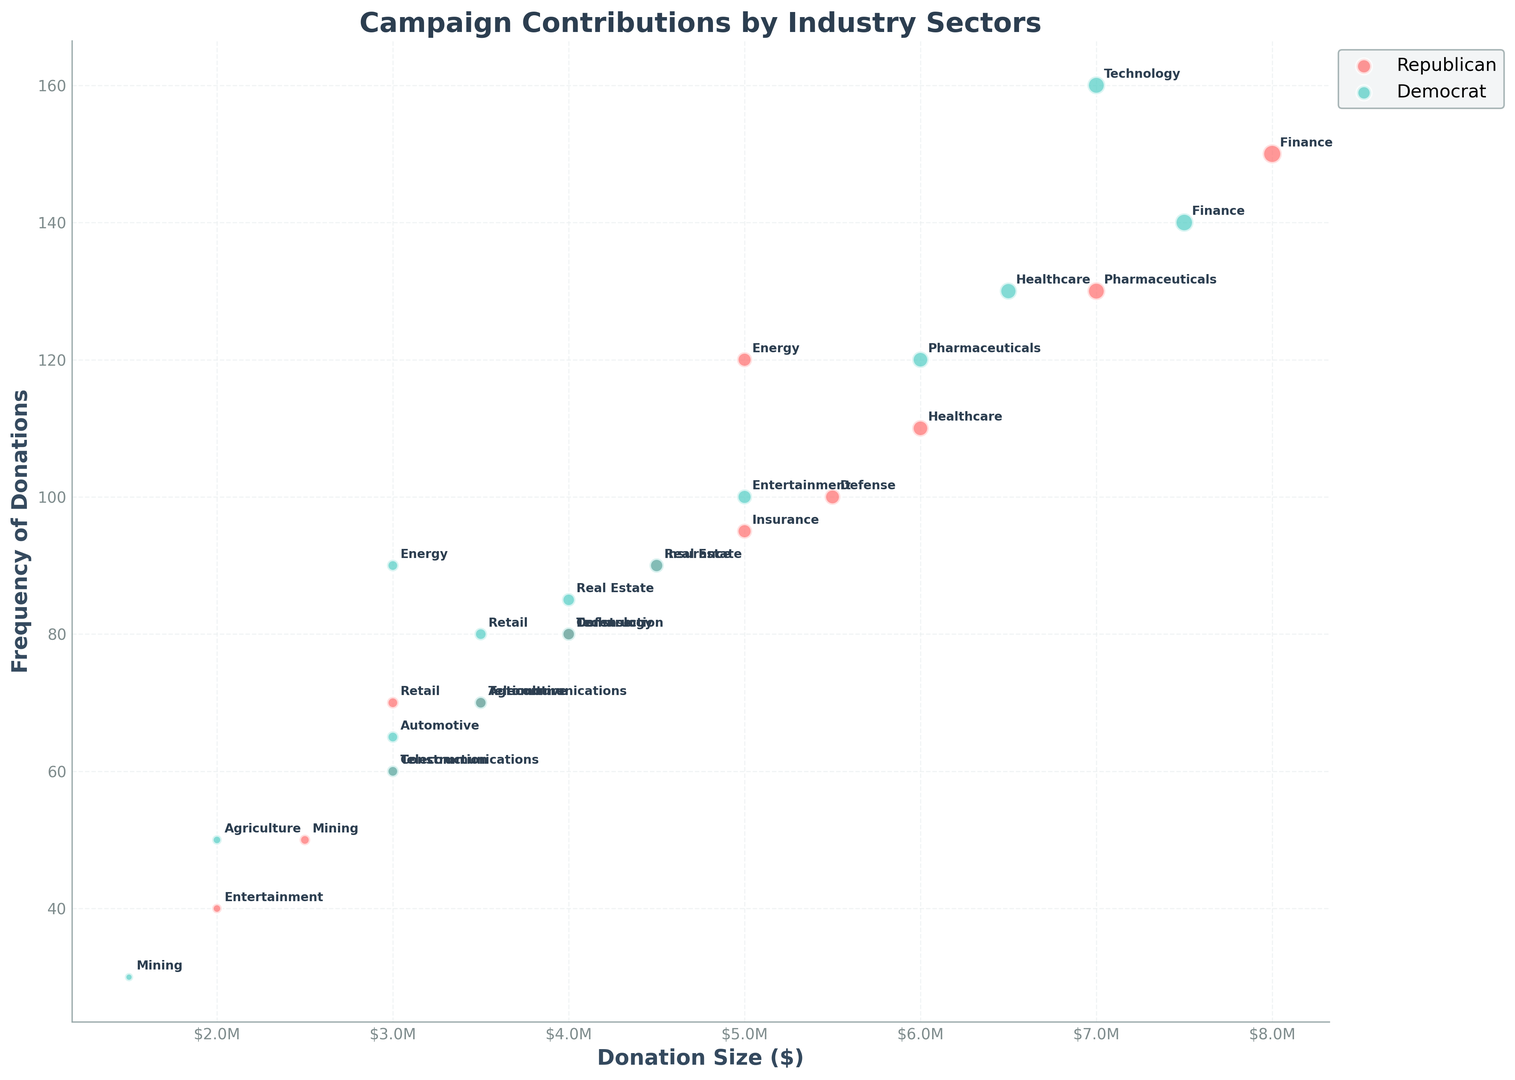Which industry contributes the largest total donation size to the Republican party? The total donation sizes to the Republican party are marked by larger bubble sizes. From the chart, the Finance sector has the largest bubble, indicating it has the largest total donation size.
Answer: Finance Which party receives more frequent contributions from the Technology sector? The Technology sector bubbles are positioned along the frequency axis. The Democrat bubble for Technology is higher on the frequency axis compared to the Republican bubble, indicating more frequent contributions.
Answer: Democrat What is the difference in average donation size between the Republican and Democrat parties, based on the Finance and Technology sectors? The Finance donations are $8M for Republicans and $7.5M for Democrats. The Technology donations are $4M for Republicans and $7M for Democrats. The average for Republicans is (8M + 4M)/2 = $6M. The average for Democrats is (7.5M + 7M)/2 = $7.25M. The difference is $7.25M - $6M = $1.25M.
Answer: $1.25M Among the Republican party's donors, which industry has the highest frequency of donations? The highest frequency of donations to the Republican party is represented by the topmost large bubble on the frequency axis. The Finance sector's bubble for Republicans is highest, indicating the most frequent contributions.
Answer: Finance Do contributions from the Energy sector show a higher frequency for any party? Which party is it? The donations from the Energy sector to the Republican and Democrat parties can be compared based on their positions on the frequency axis. The Republican bubble is higher, indicating a higher frequency of donations.
Answer: Republican Which industry has similar frequency but higher total contribution size to Democrats compared to Republicans? From the visual attributes, we can look for bubbles at similar heights (frequency) with size differences. The Technology sector shows similar frequencies but the Democrat bubble is larger, indicating a higher total contribution size to Democrats.
Answer: Technology For which industry sectors is the donation size to Democrats larger than that to Republicans, but the frequency is less? We look for Democrat bubbles larger than their Republican counterparts but lower on the frequency axis. The Pharmaceuticals sector fits this criterion with a larger donation size but a lower frequency.
Answer: Pharmaceuticals What is the difference in donation size between Republican and Democrat parties from the Real Estate sector? The Real Estate sector’s donation sizes are represented by the sizes of the bubbles. Republican donations are $4.5M and Democrat donations are $4M. The difference is $4.5M - $4M = $0.5M.
Answer: $0.5M How does the total donation size from the Entertainment sector to the Democratic party compare to the Republican party? Comparing the size of the Entertainment bubbles for both parties, the Democrat bubble is larger, indicating a larger total donation size. Democrat donations are $5M and Republican donations are $2M.
Answer: Democrat Which industry shows the least frequent contributions to the Democrat party? In terms of frequency, the Democrat party bubble lowest on the frequency axis represents the least frequent contributions. Mining sector is lowest, with a frequency of 30.
Answer: Mining 